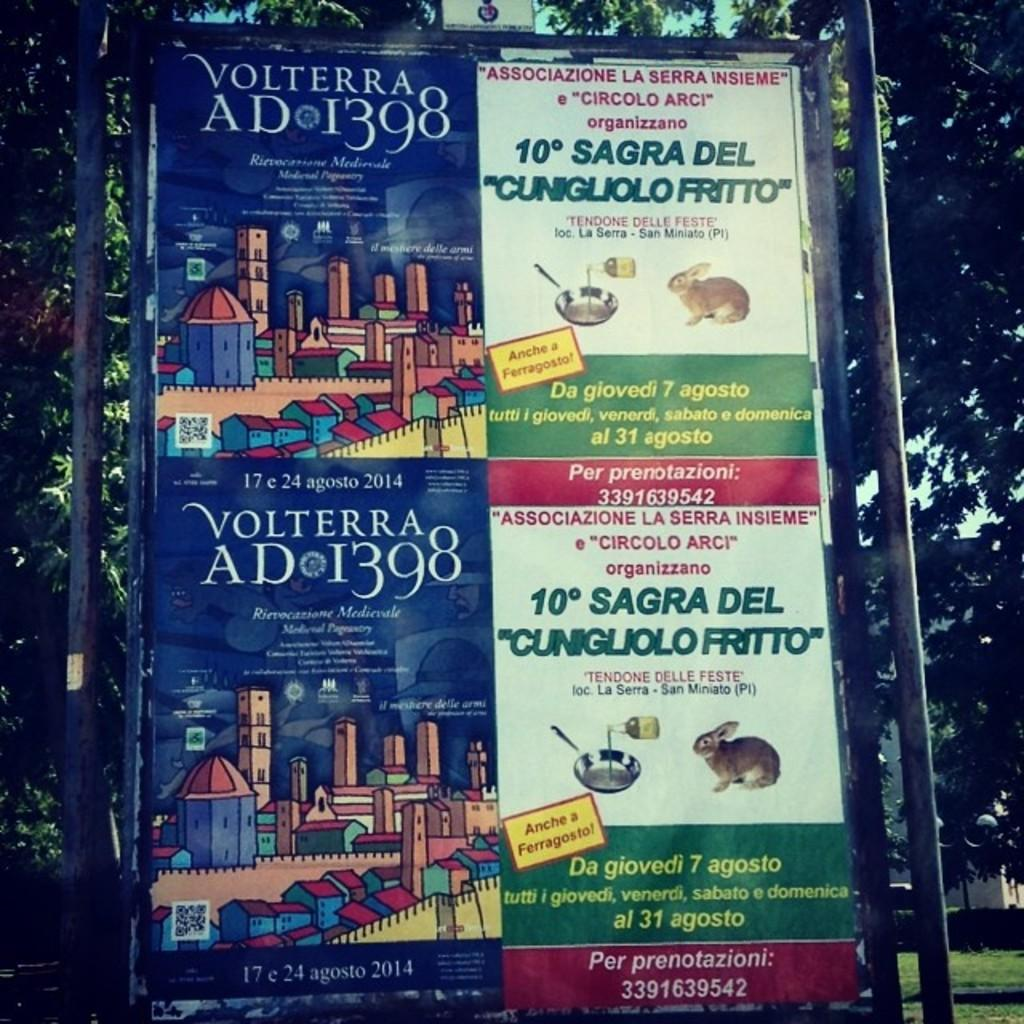What is the main object in the image with pictures and text? There is a board with pictures and text in the image. What type of natural environment can be seen in the image? Trees and grass are visible in the image. What type of structure is visible in the image? There is a building visible in the image. What part of the natural environment is visible in the image? The sky is visible in the image. What type of curve can be seen in the image? There is no curve present in the image. What time of day is depicted in the image? The time of day cannot be determined from the image, as there are no specific indicators of time. 